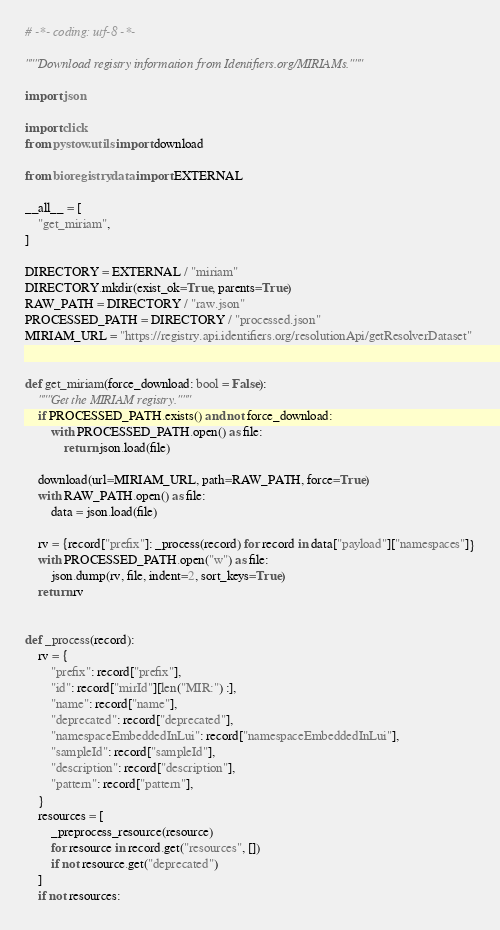<code> <loc_0><loc_0><loc_500><loc_500><_Python_># -*- coding: utf-8 -*-

"""Download registry information from Identifiers.org/MIRIAMs."""

import json

import click
from pystow.utils import download

from bioregistry.data import EXTERNAL

__all__ = [
    "get_miriam",
]

DIRECTORY = EXTERNAL / "miriam"
DIRECTORY.mkdir(exist_ok=True, parents=True)
RAW_PATH = DIRECTORY / "raw.json"
PROCESSED_PATH = DIRECTORY / "processed.json"
MIRIAM_URL = "https://registry.api.identifiers.org/resolutionApi/getResolverDataset"


def get_miriam(force_download: bool = False):
    """Get the MIRIAM registry."""
    if PROCESSED_PATH.exists() and not force_download:
        with PROCESSED_PATH.open() as file:
            return json.load(file)

    download(url=MIRIAM_URL, path=RAW_PATH, force=True)
    with RAW_PATH.open() as file:
        data = json.load(file)

    rv = {record["prefix"]: _process(record) for record in data["payload"]["namespaces"]}
    with PROCESSED_PATH.open("w") as file:
        json.dump(rv, file, indent=2, sort_keys=True)
    return rv


def _process(record):
    rv = {
        "prefix": record["prefix"],
        "id": record["mirId"][len("MIR:") :],
        "name": record["name"],
        "deprecated": record["deprecated"],
        "namespaceEmbeddedInLui": record["namespaceEmbeddedInLui"],
        "sampleId": record["sampleId"],
        "description": record["description"],
        "pattern": record["pattern"],
    }
    resources = [
        _preprocess_resource(resource)
        for resource in record.get("resources", [])
        if not resource.get("deprecated")
    ]
    if not resources:</code> 